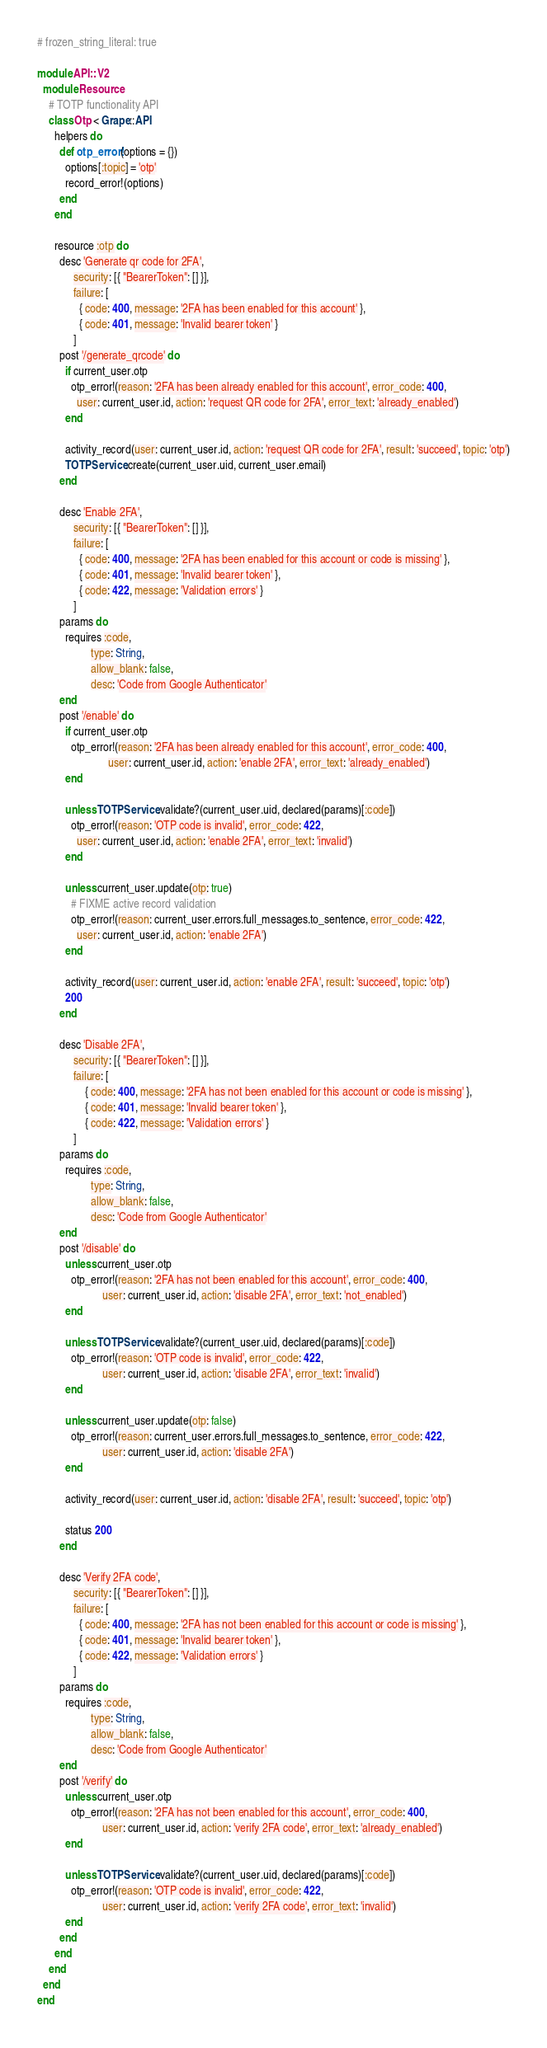Convert code to text. <code><loc_0><loc_0><loc_500><loc_500><_Ruby_># frozen_string_literal: true

module API::V2
  module Resource
    # TOTP functionality API
    class Otp < Grape::API
      helpers do
        def otp_error!(options = {})
          options[:topic] = 'otp'
          record_error!(options)
        end
      end

      resource :otp do
        desc 'Generate qr code for 2FA',
             security: [{ "BearerToken": [] }],
             failure: [
               { code: 400, message: '2FA has been enabled for this account' },
               { code: 401, message: 'Invalid bearer token' }
             ]
        post '/generate_qrcode' do
          if current_user.otp
            otp_error!(reason: '2FA has been already enabled for this account', error_code: 400,
              user: current_user.id, action: 'request QR code for 2FA', error_text: 'already_enabled')
          end

          activity_record(user: current_user.id, action: 'request QR code for 2FA', result: 'succeed', topic: 'otp')
          TOTPService.create(current_user.uid, current_user.email)
        end

        desc 'Enable 2FA',
             security: [{ "BearerToken": [] }],
             failure: [
               { code: 400, message: '2FA has been enabled for this account or code is missing' },
               { code: 401, message: 'Invalid bearer token' },
               { code: 422, message: 'Validation errors' }
             ]
        params do
          requires :code,
                   type: String,
                   allow_blank: false,
                   desc: 'Code from Google Authenticator'
        end
        post '/enable' do
          if current_user.otp
            otp_error!(reason: '2FA has been already enabled for this account', error_code: 400,
                         user: current_user.id, action: 'enable 2FA', error_text: 'already_enabled')
          end

          unless TOTPService.validate?(current_user.uid, declared(params)[:code])
            otp_error!(reason: 'OTP code is invalid', error_code: 422,
              user: current_user.id, action: 'enable 2FA', error_text: 'invalid')
          end

          unless current_user.update(otp: true)
            # FIXME active record validation
            otp_error!(reason: current_user.errors.full_messages.to_sentence, error_code: 422,
              user: current_user.id, action: 'enable 2FA')
          end

          activity_record(user: current_user.id, action: 'enable 2FA', result: 'succeed', topic: 'otp')
          200
        end

        desc 'Disable 2FA',
             security: [{ "BearerToken": [] }],
             failure: [
                 { code: 400, message: '2FA has not been enabled for this account or code is missing' },
                 { code: 401, message: 'Invalid bearer token' },
                 { code: 422, message: 'Validation errors' }
             ]
        params do
          requires :code,
                   type: String,
                   allow_blank: false,
                   desc: 'Code from Google Authenticator'
        end
        post '/disable' do
          unless current_user.otp
            otp_error!(reason: '2FA has not been enabled for this account', error_code: 400,
                       user: current_user.id, action: 'disable 2FA', error_text: 'not_enabled')
          end

          unless TOTPService.validate?(current_user.uid, declared(params)[:code])
            otp_error!(reason: 'OTP code is invalid', error_code: 422,
                       user: current_user.id, action: 'disable 2FA', error_text: 'invalid')
          end

          unless current_user.update(otp: false)
            otp_error!(reason: current_user.errors.full_messages.to_sentence, error_code: 422,
                       user: current_user.id, action: 'disable 2FA')
          end

          activity_record(user: current_user.id, action: 'disable 2FA', result: 'succeed', topic: 'otp')

          status 200
        end

        desc 'Verify 2FA code',
             security: [{ "BearerToken": [] }],
             failure: [
               { code: 400, message: '2FA has not been enabled for this account or code is missing' },
               { code: 401, message: 'Invalid bearer token' },
               { code: 422, message: 'Validation errors' }
             ]
        params do
          requires :code,
                   type: String,
                   allow_blank: false,
                   desc: 'Code from Google Authenticator'
        end
        post '/verify' do
          unless current_user.otp
            otp_error!(reason: '2FA has not been enabled for this account', error_code: 400,
                       user: current_user.id, action: 'verify 2FA code', error_text: 'already_enabled')
          end

          unless TOTPService.validate?(current_user.uid, declared(params)[:code])
            otp_error!(reason: 'OTP code is invalid', error_code: 422,
                       user: current_user.id, action: 'verify 2FA code', error_text: 'invalid')
          end
        end
      end
    end
  end
end
</code> 